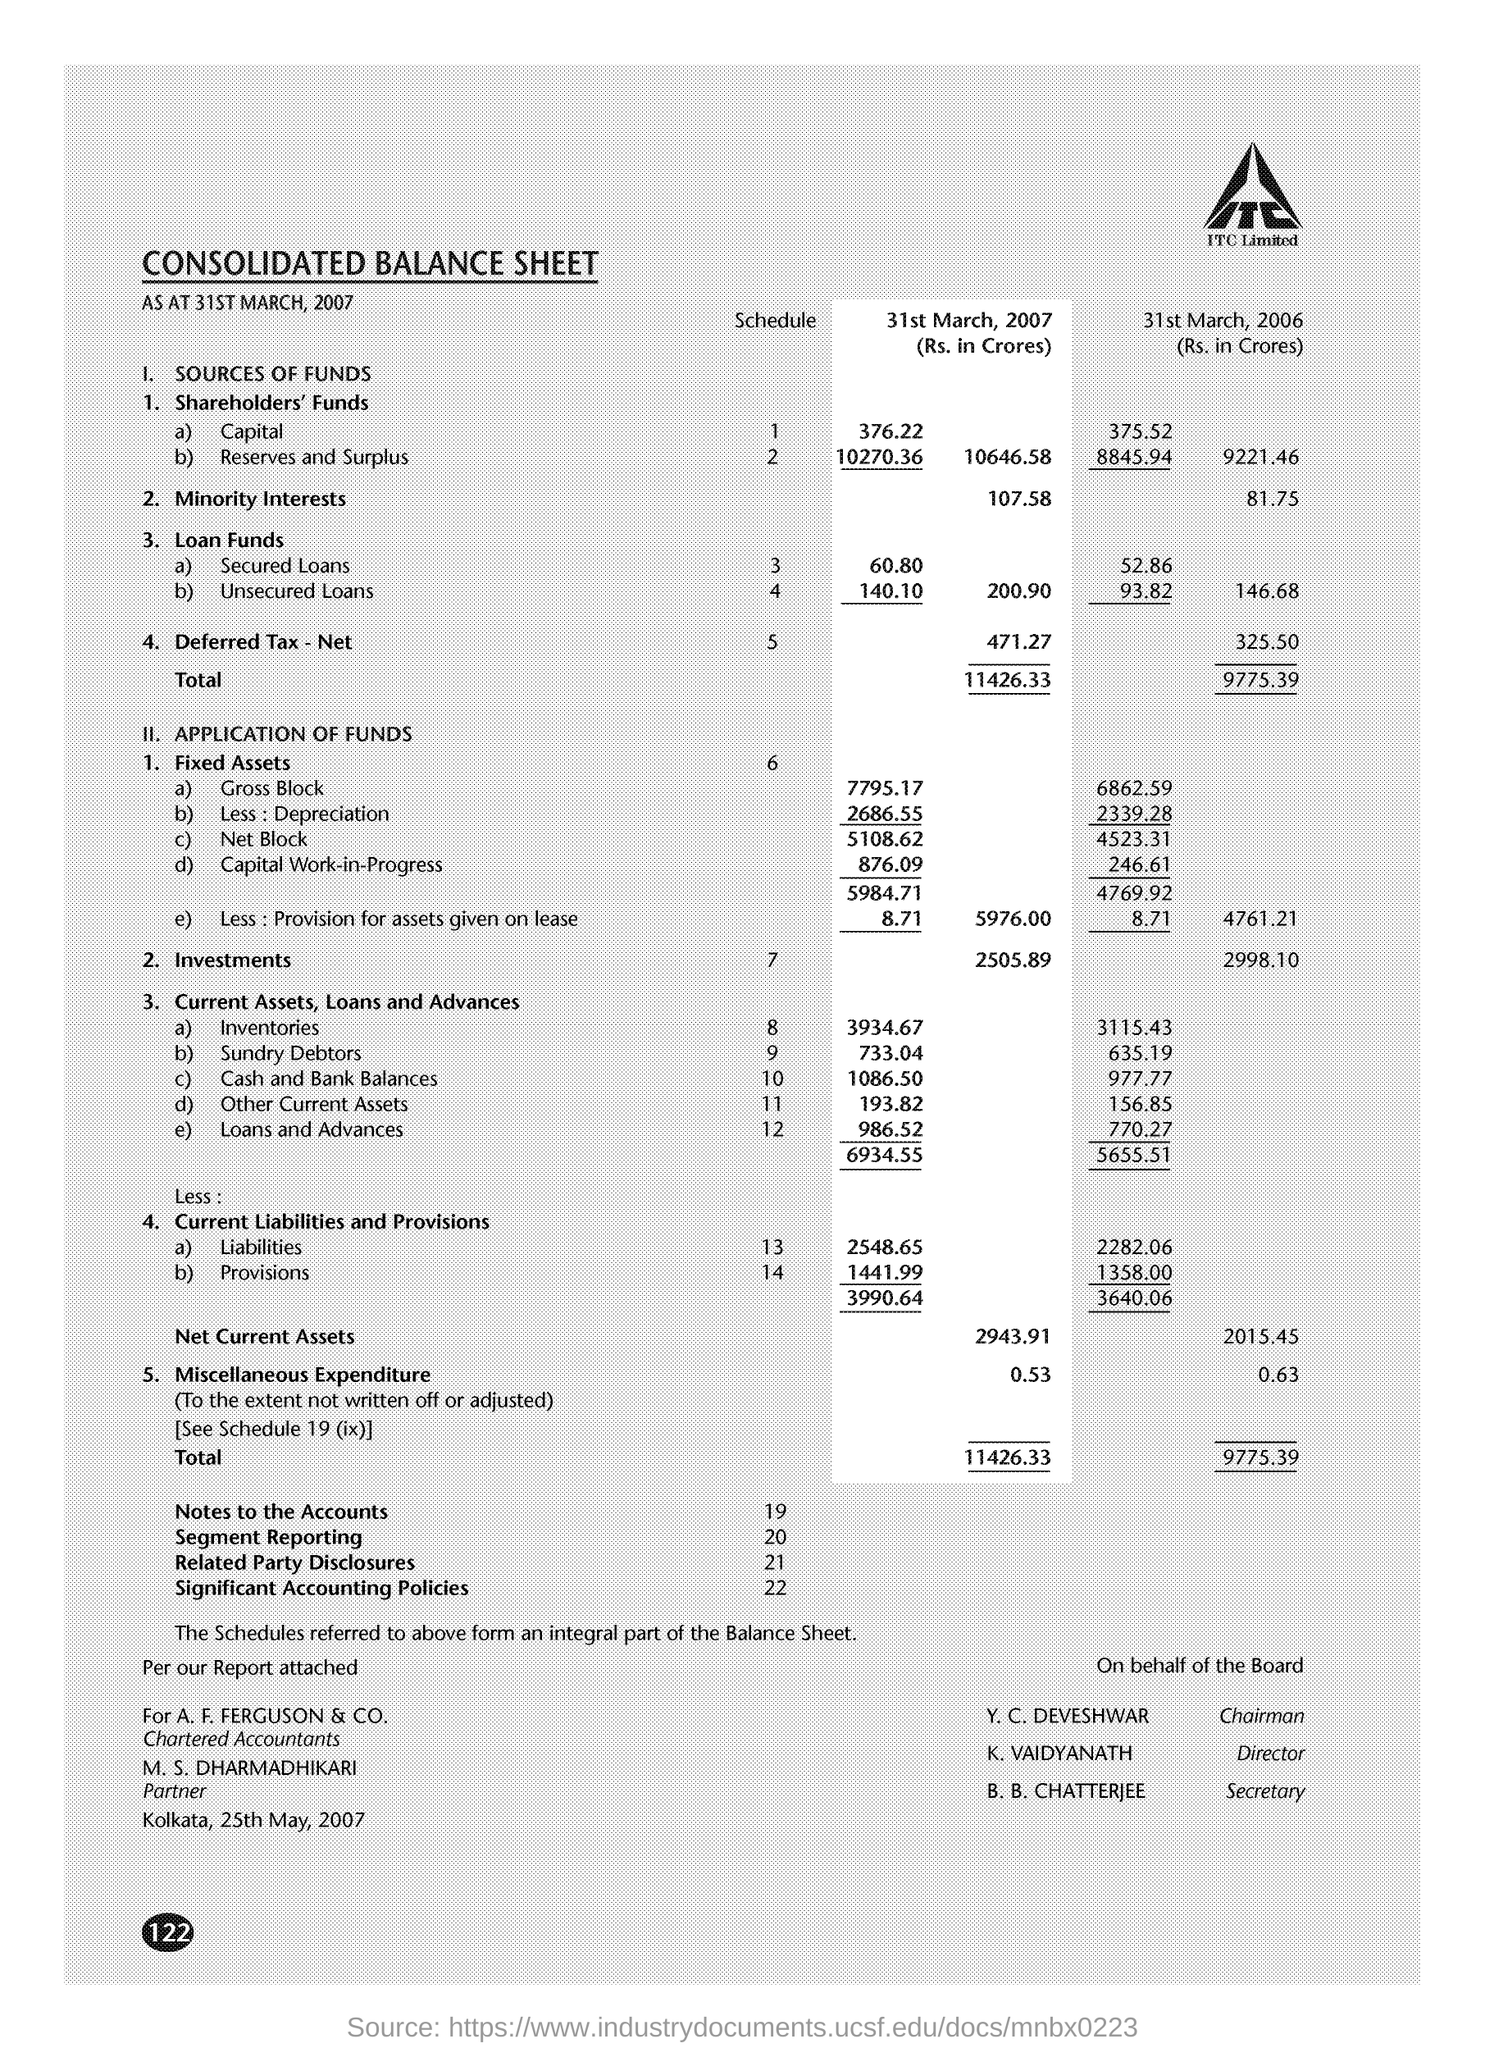What was the total of the 'Secured Loans' and 'Unsecured Loans' under 'Loan Funds' for the year ending 31st March 2007? The total of 'Secured Loans' and 'Unsecured Loans' under 'Loan Funds' for the year ending 31st March 2007 was ₹210.90 Crores. 